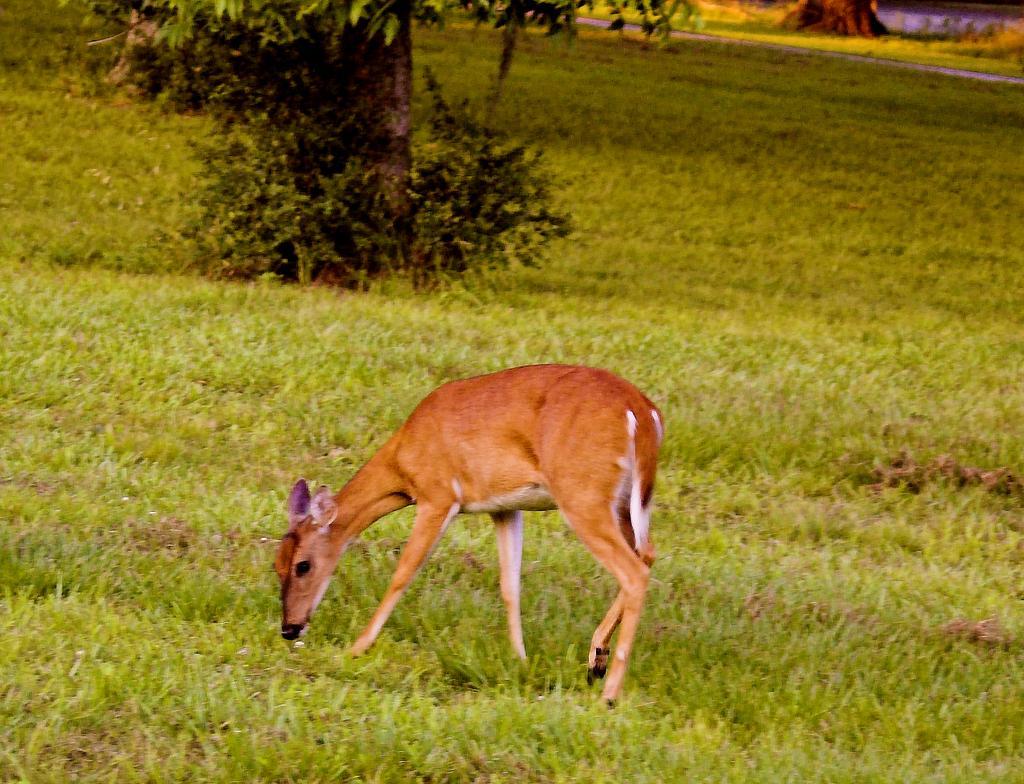Could you give a brief overview of what you see in this image? In this image I can see an open grass ground and in the front I can see a brown colour door is standing. In the background I can see few plants and a tree. 